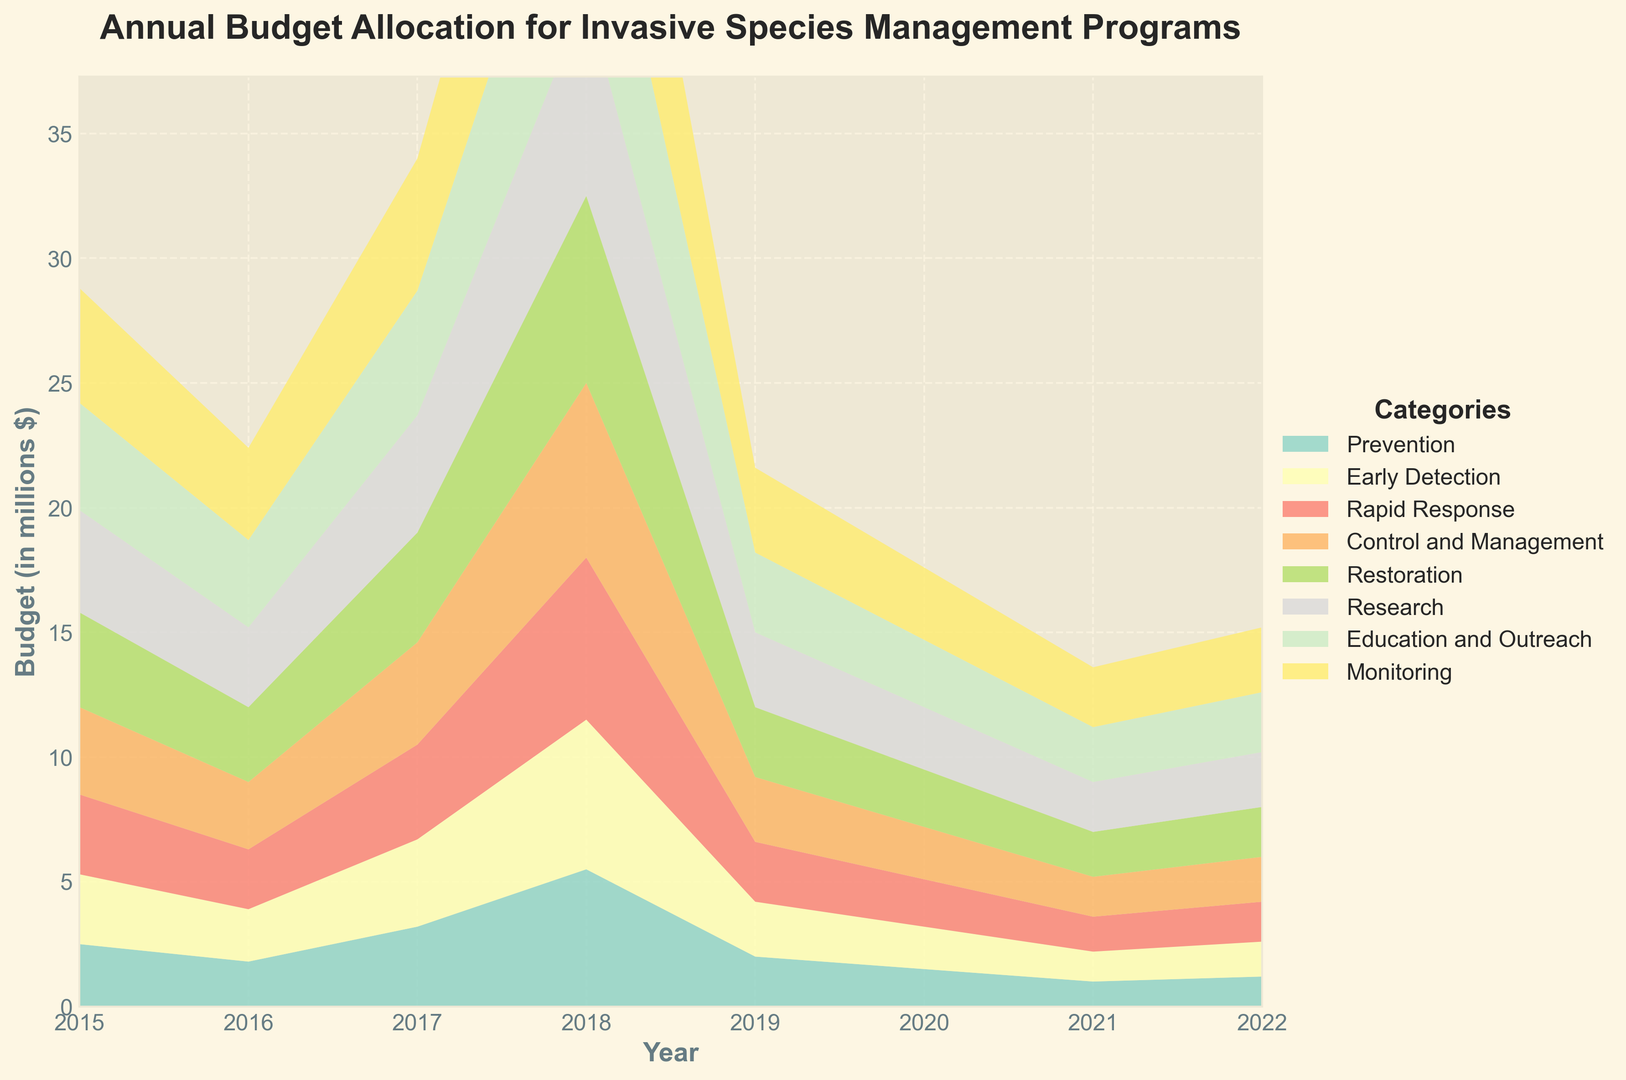Which category had the highest budget allocation in 2015? To find the category with the highest budget allocation in 2015, look at the starting point of each colored area in the area chart. The largest starting value belongs to "Control and Management".
Answer: Control and Management How did the budget for Early Detection change from 2015 to 2022? Compare the height of the Early Detection section in 2015 and 2022. In 2015, it was 1.8 million, and in 2022, it was 3.7 million. Calculate the change: 3.7 - 1.8 = 1.9 million increase.
Answer: Increased by 1.9 million What was the total budget allocated for all categories in 2022? Sum the heights of all categories in 2022. Prevention (4.6) + Early Detection (3.7) + Rapid Response (5.3) + Control and Management (9.0) + Restoration (3.4) + Research (2.9) + Education and Outreach (2.4) + Monitoring (2.6). The sum is 34.9 million.
Answer: 34.9 million Which category saw the fastest growth in budget allocation from 2015 to 2022? Calculate the difference in budgets for all categories between 2015 and 2022. Prevention (4.6 - 2.5 = 2.1), Early Detection (3.7 - 1.8 = 1.9), Rapid Response (5.3 - 3.2 = 2.1), Control and Management (9.0 - 5.5 = 3.5), Restoration (3.4 - 2.0 = 1.4), Research (2.9 - 1.5 = 1.4), Education and Outreach (2.4 - 1.0 = 1.4), Monitoring (2.6 - 1.2 = 1.4). Control and Management has the largest difference (3.5).
Answer: Control and Management What was the total budget allocated to Research and Education and Outreach in 2020? Find and sum the budgets for Research (2.5) and Education and Outreach (2.0) in 2020. 2.5 + 2.0 = 4.5 million.
Answer: 4.5 million Compare the budget allocation for Prevention and Rapid Response in 2019. Which category had a higher allocation? Look at the heights of the Prevention and Rapid Response sections in 2019. Prevention had 3.8 million, and Rapid Response had 4.4 million. Rapid Response is higher.
Answer: Rapid Response Which year had the smallest total budget allocation for all categories combined? Sum the budget for all categories across each year and compare. The smallest sum occurs in 2015 with (2.5 + 1.8 + 3.2 + 5.5 + 2.0 + 1.5 + 1.0 + 1.2 = 18.7).
Answer: 2015 What was the average annual increase in budget for Control and Management from 2015 to 2022? The total increase for Control and Management from 2015 to 2022 is (9.0 - 5.5 = 3.5). Divide this increase by the number of years (2022 - 2015 = 7). 3.5 / 7 = 0.5 million per year.
Answer: 0.5 million per year For 2021, which two categories had the most similar budget allocations? Compare the budget values for all categories in 2021. Prevention (4.3), Early Detection (3.5), Rapid Response (5.0), Control and Management (8.5), Restoration (3.2), Research (2.7), Education and Outreach (2.2), Monitoring (2.4). The closest values are Monitoring (2.4) and Education and Outreach (2.2), difference = 0.2.
Answer: Monitoring and Education and Outreach Which category consistently increased in budget every year from 2015 to 2022? Observe the trend of each category over the years. All categories show a consistent increase each year without any drop: Prevention, Early Detection, Rapid Response, Control and Management, Restoration, Research, Education and Outreach, Monitoring.
Answer: All categories 